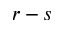<formula> <loc_0><loc_0><loc_500><loc_500>r - s</formula> 